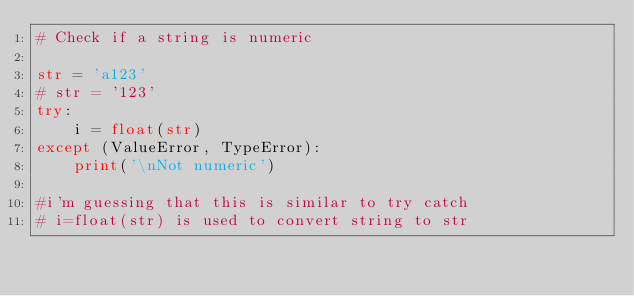Convert code to text. <code><loc_0><loc_0><loc_500><loc_500><_Python_># Check if a string is numeric

str = 'a123'
# str = '123'
try:
    i = float(str)
except (ValueError, TypeError):
    print('\nNot numeric')

#i'm guessing that this is similar to try catch
# i=float(str) is used to convert string to str</code> 